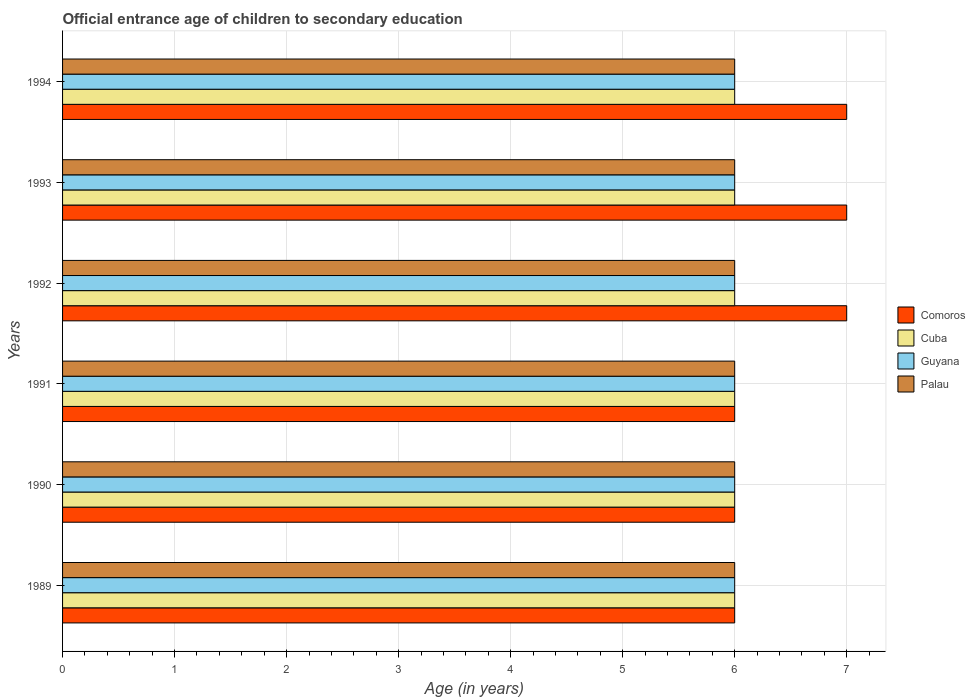Are the number of bars per tick equal to the number of legend labels?
Your answer should be very brief. Yes. Are the number of bars on each tick of the Y-axis equal?
Offer a very short reply. Yes. How many bars are there on the 2nd tick from the top?
Offer a terse response. 4. Across all years, what is the minimum secondary school starting age of children in Guyana?
Provide a short and direct response. 6. What is the difference between the secondary school starting age of children in Comoros in 1992 and the secondary school starting age of children in Cuba in 1989?
Provide a short and direct response. 1. What is the ratio of the secondary school starting age of children in Comoros in 1990 to that in 1993?
Offer a terse response. 0.86. What is the difference between the highest and the lowest secondary school starting age of children in Comoros?
Your response must be concise. 1. In how many years, is the secondary school starting age of children in Palau greater than the average secondary school starting age of children in Palau taken over all years?
Give a very brief answer. 0. What does the 2nd bar from the top in 1990 represents?
Make the answer very short. Guyana. What does the 4th bar from the bottom in 1994 represents?
Give a very brief answer. Palau. Is it the case that in every year, the sum of the secondary school starting age of children in Comoros and secondary school starting age of children in Palau is greater than the secondary school starting age of children in Cuba?
Provide a succinct answer. Yes. Are all the bars in the graph horizontal?
Offer a terse response. Yes. How many years are there in the graph?
Your answer should be very brief. 6. How many legend labels are there?
Keep it short and to the point. 4. How are the legend labels stacked?
Ensure brevity in your answer.  Vertical. What is the title of the graph?
Ensure brevity in your answer.  Official entrance age of children to secondary education. Does "French Polynesia" appear as one of the legend labels in the graph?
Keep it short and to the point. No. What is the label or title of the X-axis?
Keep it short and to the point. Age (in years). What is the label or title of the Y-axis?
Provide a short and direct response. Years. What is the Age (in years) of Comoros in 1989?
Make the answer very short. 6. What is the Age (in years) of Comoros in 1990?
Your response must be concise. 6. What is the Age (in years) in Guyana in 1990?
Offer a very short reply. 6. What is the Age (in years) in Palau in 1990?
Provide a succinct answer. 6. What is the Age (in years) of Comoros in 1991?
Provide a short and direct response. 6. What is the Age (in years) of Cuba in 1991?
Offer a terse response. 6. What is the Age (in years) of Palau in 1991?
Your answer should be very brief. 6. What is the Age (in years) in Comoros in 1992?
Provide a short and direct response. 7. What is the Age (in years) in Guyana in 1992?
Provide a succinct answer. 6. What is the Age (in years) of Comoros in 1994?
Make the answer very short. 7. What is the Age (in years) in Cuba in 1994?
Keep it short and to the point. 6. What is the Age (in years) in Guyana in 1994?
Offer a terse response. 6. Across all years, what is the maximum Age (in years) in Comoros?
Offer a terse response. 7. Across all years, what is the maximum Age (in years) of Guyana?
Your response must be concise. 6. Across all years, what is the minimum Age (in years) in Comoros?
Give a very brief answer. 6. Across all years, what is the minimum Age (in years) of Cuba?
Offer a very short reply. 6. What is the total Age (in years) of Cuba in the graph?
Your answer should be very brief. 36. What is the total Age (in years) of Guyana in the graph?
Provide a succinct answer. 36. What is the total Age (in years) of Palau in the graph?
Keep it short and to the point. 36. What is the difference between the Age (in years) in Comoros in 1989 and that in 1990?
Offer a terse response. 0. What is the difference between the Age (in years) of Comoros in 1989 and that in 1991?
Offer a terse response. 0. What is the difference between the Age (in years) of Guyana in 1989 and that in 1991?
Your answer should be very brief. 0. What is the difference between the Age (in years) in Cuba in 1989 and that in 1992?
Provide a short and direct response. 0. What is the difference between the Age (in years) in Palau in 1989 and that in 1993?
Your response must be concise. 0. What is the difference between the Age (in years) of Comoros in 1989 and that in 1994?
Your answer should be compact. -1. What is the difference between the Age (in years) in Comoros in 1990 and that in 1991?
Your answer should be very brief. 0. What is the difference between the Age (in years) in Cuba in 1990 and that in 1991?
Your answer should be very brief. 0. What is the difference between the Age (in years) of Palau in 1990 and that in 1991?
Your answer should be compact. 0. What is the difference between the Age (in years) in Guyana in 1990 and that in 1992?
Offer a very short reply. 0. What is the difference between the Age (in years) in Palau in 1990 and that in 1992?
Provide a succinct answer. 0. What is the difference between the Age (in years) in Guyana in 1990 and that in 1993?
Provide a succinct answer. 0. What is the difference between the Age (in years) in Comoros in 1990 and that in 1994?
Ensure brevity in your answer.  -1. What is the difference between the Age (in years) in Cuba in 1990 and that in 1994?
Your response must be concise. 0. What is the difference between the Age (in years) of Palau in 1990 and that in 1994?
Provide a short and direct response. 0. What is the difference between the Age (in years) in Comoros in 1991 and that in 1992?
Offer a terse response. -1. What is the difference between the Age (in years) of Cuba in 1991 and that in 1992?
Provide a succinct answer. 0. What is the difference between the Age (in years) of Palau in 1991 and that in 1992?
Your response must be concise. 0. What is the difference between the Age (in years) of Comoros in 1991 and that in 1993?
Provide a succinct answer. -1. What is the difference between the Age (in years) in Cuba in 1991 and that in 1993?
Ensure brevity in your answer.  0. What is the difference between the Age (in years) in Guyana in 1991 and that in 1993?
Your answer should be very brief. 0. What is the difference between the Age (in years) of Palau in 1991 and that in 1993?
Your response must be concise. 0. What is the difference between the Age (in years) in Comoros in 1991 and that in 1994?
Your response must be concise. -1. What is the difference between the Age (in years) in Cuba in 1991 and that in 1994?
Offer a very short reply. 0. What is the difference between the Age (in years) of Cuba in 1992 and that in 1993?
Your response must be concise. 0. What is the difference between the Age (in years) of Comoros in 1992 and that in 1994?
Your answer should be compact. 0. What is the difference between the Age (in years) of Cuba in 1992 and that in 1994?
Provide a short and direct response. 0. What is the difference between the Age (in years) of Guyana in 1992 and that in 1994?
Ensure brevity in your answer.  0. What is the difference between the Age (in years) in Comoros in 1989 and the Age (in years) in Palau in 1990?
Ensure brevity in your answer.  0. What is the difference between the Age (in years) in Cuba in 1989 and the Age (in years) in Guyana in 1990?
Your answer should be compact. 0. What is the difference between the Age (in years) of Comoros in 1989 and the Age (in years) of Cuba in 1991?
Provide a succinct answer. 0. What is the difference between the Age (in years) in Comoros in 1989 and the Age (in years) in Guyana in 1991?
Offer a very short reply. 0. What is the difference between the Age (in years) of Comoros in 1989 and the Age (in years) of Palau in 1991?
Offer a very short reply. 0. What is the difference between the Age (in years) in Guyana in 1989 and the Age (in years) in Palau in 1991?
Ensure brevity in your answer.  0. What is the difference between the Age (in years) of Comoros in 1989 and the Age (in years) of Guyana in 1992?
Make the answer very short. 0. What is the difference between the Age (in years) in Comoros in 1989 and the Age (in years) in Palau in 1992?
Your response must be concise. 0. What is the difference between the Age (in years) of Cuba in 1989 and the Age (in years) of Guyana in 1992?
Offer a terse response. 0. What is the difference between the Age (in years) of Comoros in 1989 and the Age (in years) of Palau in 1993?
Make the answer very short. 0. What is the difference between the Age (in years) of Guyana in 1989 and the Age (in years) of Palau in 1993?
Keep it short and to the point. 0. What is the difference between the Age (in years) of Comoros in 1989 and the Age (in years) of Palau in 1994?
Offer a very short reply. 0. What is the difference between the Age (in years) of Guyana in 1989 and the Age (in years) of Palau in 1994?
Give a very brief answer. 0. What is the difference between the Age (in years) in Comoros in 1990 and the Age (in years) in Cuba in 1991?
Give a very brief answer. 0. What is the difference between the Age (in years) in Comoros in 1990 and the Age (in years) in Guyana in 1991?
Give a very brief answer. 0. What is the difference between the Age (in years) of Comoros in 1990 and the Age (in years) of Palau in 1991?
Offer a very short reply. 0. What is the difference between the Age (in years) in Comoros in 1990 and the Age (in years) in Cuba in 1992?
Your answer should be compact. 0. What is the difference between the Age (in years) in Comoros in 1990 and the Age (in years) in Palau in 1992?
Provide a succinct answer. 0. What is the difference between the Age (in years) in Cuba in 1990 and the Age (in years) in Guyana in 1992?
Provide a short and direct response. 0. What is the difference between the Age (in years) in Cuba in 1990 and the Age (in years) in Palau in 1992?
Provide a succinct answer. 0. What is the difference between the Age (in years) of Comoros in 1990 and the Age (in years) of Cuba in 1993?
Provide a succinct answer. 0. What is the difference between the Age (in years) of Comoros in 1990 and the Age (in years) of Palau in 1993?
Your answer should be very brief. 0. What is the difference between the Age (in years) in Cuba in 1990 and the Age (in years) in Guyana in 1993?
Ensure brevity in your answer.  0. What is the difference between the Age (in years) of Guyana in 1990 and the Age (in years) of Palau in 1993?
Your answer should be compact. 0. What is the difference between the Age (in years) of Cuba in 1990 and the Age (in years) of Palau in 1994?
Your answer should be compact. 0. What is the difference between the Age (in years) in Guyana in 1990 and the Age (in years) in Palau in 1994?
Ensure brevity in your answer.  0. What is the difference between the Age (in years) in Comoros in 1991 and the Age (in years) in Guyana in 1992?
Make the answer very short. 0. What is the difference between the Age (in years) of Comoros in 1991 and the Age (in years) of Palau in 1992?
Ensure brevity in your answer.  0. What is the difference between the Age (in years) of Cuba in 1991 and the Age (in years) of Guyana in 1992?
Offer a very short reply. 0. What is the difference between the Age (in years) in Cuba in 1991 and the Age (in years) in Palau in 1992?
Keep it short and to the point. 0. What is the difference between the Age (in years) of Comoros in 1991 and the Age (in years) of Guyana in 1993?
Your answer should be very brief. 0. What is the difference between the Age (in years) of Comoros in 1991 and the Age (in years) of Palau in 1993?
Your response must be concise. 0. What is the difference between the Age (in years) of Cuba in 1991 and the Age (in years) of Guyana in 1993?
Give a very brief answer. 0. What is the difference between the Age (in years) in Comoros in 1991 and the Age (in years) in Guyana in 1994?
Your answer should be very brief. 0. What is the difference between the Age (in years) of Comoros in 1991 and the Age (in years) of Palau in 1994?
Provide a succinct answer. 0. What is the difference between the Age (in years) in Guyana in 1991 and the Age (in years) in Palau in 1994?
Provide a short and direct response. 0. What is the difference between the Age (in years) of Comoros in 1992 and the Age (in years) of Guyana in 1993?
Your answer should be very brief. 1. What is the difference between the Age (in years) of Cuba in 1992 and the Age (in years) of Palau in 1993?
Your answer should be very brief. 0. What is the difference between the Age (in years) in Guyana in 1992 and the Age (in years) in Palau in 1993?
Ensure brevity in your answer.  0. What is the difference between the Age (in years) of Comoros in 1992 and the Age (in years) of Cuba in 1994?
Offer a very short reply. 1. What is the difference between the Age (in years) of Comoros in 1992 and the Age (in years) of Guyana in 1994?
Make the answer very short. 1. What is the difference between the Age (in years) in Comoros in 1992 and the Age (in years) in Palau in 1994?
Offer a very short reply. 1. What is the difference between the Age (in years) in Guyana in 1992 and the Age (in years) in Palau in 1994?
Give a very brief answer. 0. What is the difference between the Age (in years) of Comoros in 1993 and the Age (in years) of Cuba in 1994?
Provide a succinct answer. 1. What is the difference between the Age (in years) in Comoros in 1993 and the Age (in years) in Palau in 1994?
Provide a short and direct response. 1. What is the difference between the Age (in years) in Guyana in 1993 and the Age (in years) in Palau in 1994?
Provide a succinct answer. 0. What is the average Age (in years) of Cuba per year?
Your answer should be compact. 6. What is the average Age (in years) in Palau per year?
Offer a very short reply. 6. In the year 1989, what is the difference between the Age (in years) in Comoros and Age (in years) in Cuba?
Your answer should be compact. 0. In the year 1989, what is the difference between the Age (in years) of Comoros and Age (in years) of Guyana?
Provide a short and direct response. 0. In the year 1989, what is the difference between the Age (in years) in Guyana and Age (in years) in Palau?
Provide a succinct answer. 0. In the year 1990, what is the difference between the Age (in years) of Comoros and Age (in years) of Guyana?
Offer a terse response. 0. In the year 1990, what is the difference between the Age (in years) in Comoros and Age (in years) in Palau?
Offer a very short reply. 0. In the year 1992, what is the difference between the Age (in years) of Comoros and Age (in years) of Palau?
Offer a terse response. 1. In the year 1992, what is the difference between the Age (in years) of Cuba and Age (in years) of Palau?
Your response must be concise. 0. In the year 1992, what is the difference between the Age (in years) in Guyana and Age (in years) in Palau?
Your answer should be compact. 0. In the year 1993, what is the difference between the Age (in years) of Comoros and Age (in years) of Cuba?
Your response must be concise. 1. In the year 1993, what is the difference between the Age (in years) in Comoros and Age (in years) in Palau?
Provide a succinct answer. 1. In the year 1993, what is the difference between the Age (in years) in Cuba and Age (in years) in Guyana?
Your answer should be compact. 0. In the year 1993, what is the difference between the Age (in years) of Guyana and Age (in years) of Palau?
Your answer should be very brief. 0. In the year 1994, what is the difference between the Age (in years) in Comoros and Age (in years) in Palau?
Give a very brief answer. 1. In the year 1994, what is the difference between the Age (in years) of Guyana and Age (in years) of Palau?
Your answer should be very brief. 0. What is the ratio of the Age (in years) of Comoros in 1989 to that in 1990?
Provide a short and direct response. 1. What is the ratio of the Age (in years) of Cuba in 1989 to that in 1990?
Make the answer very short. 1. What is the ratio of the Age (in years) of Guyana in 1989 to that in 1990?
Make the answer very short. 1. What is the ratio of the Age (in years) of Comoros in 1989 to that in 1991?
Provide a succinct answer. 1. What is the ratio of the Age (in years) of Cuba in 1989 to that in 1991?
Your answer should be very brief. 1. What is the ratio of the Age (in years) in Palau in 1989 to that in 1991?
Offer a terse response. 1. What is the ratio of the Age (in years) of Palau in 1989 to that in 1992?
Your answer should be compact. 1. What is the ratio of the Age (in years) in Comoros in 1989 to that in 1993?
Provide a succinct answer. 0.86. What is the ratio of the Age (in years) of Guyana in 1989 to that in 1993?
Keep it short and to the point. 1. What is the ratio of the Age (in years) of Palau in 1989 to that in 1993?
Your response must be concise. 1. What is the ratio of the Age (in years) of Comoros in 1989 to that in 1994?
Your answer should be compact. 0.86. What is the ratio of the Age (in years) in Cuba in 1989 to that in 1994?
Ensure brevity in your answer.  1. What is the ratio of the Age (in years) in Comoros in 1990 to that in 1994?
Make the answer very short. 0.86. What is the ratio of the Age (in years) of Guyana in 1990 to that in 1994?
Your answer should be compact. 1. What is the ratio of the Age (in years) of Palau in 1990 to that in 1994?
Your response must be concise. 1. What is the ratio of the Age (in years) in Cuba in 1991 to that in 1992?
Your response must be concise. 1. What is the ratio of the Age (in years) of Palau in 1991 to that in 1993?
Your answer should be compact. 1. What is the ratio of the Age (in years) in Comoros in 1991 to that in 1994?
Provide a succinct answer. 0.86. What is the ratio of the Age (in years) of Cuba in 1991 to that in 1994?
Keep it short and to the point. 1. What is the ratio of the Age (in years) in Comoros in 1992 to that in 1994?
Your answer should be compact. 1. What is the ratio of the Age (in years) in Cuba in 1992 to that in 1994?
Offer a very short reply. 1. What is the ratio of the Age (in years) in Cuba in 1993 to that in 1994?
Offer a very short reply. 1. What is the ratio of the Age (in years) in Palau in 1993 to that in 1994?
Offer a terse response. 1. What is the difference between the highest and the second highest Age (in years) of Guyana?
Keep it short and to the point. 0. What is the difference between the highest and the second highest Age (in years) in Palau?
Keep it short and to the point. 0. What is the difference between the highest and the lowest Age (in years) in Palau?
Your answer should be very brief. 0. 